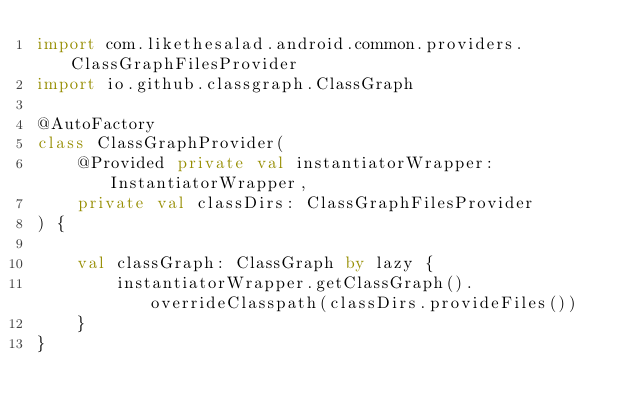<code> <loc_0><loc_0><loc_500><loc_500><_Kotlin_>import com.likethesalad.android.common.providers.ClassGraphFilesProvider
import io.github.classgraph.ClassGraph

@AutoFactory
class ClassGraphProvider(
    @Provided private val instantiatorWrapper: InstantiatorWrapper,
    private val classDirs: ClassGraphFilesProvider
) {

    val classGraph: ClassGraph by lazy {
        instantiatorWrapper.getClassGraph().overrideClasspath(classDirs.provideFiles())
    }
}</code> 